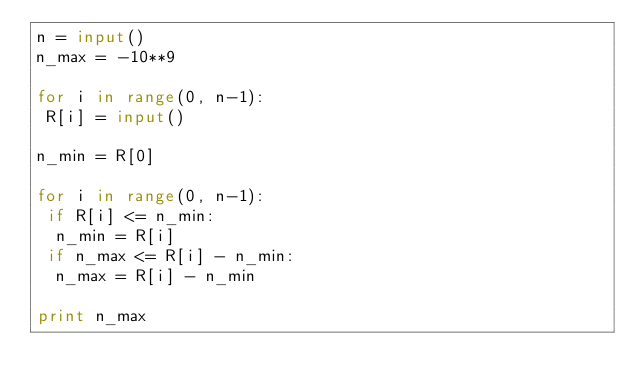<code> <loc_0><loc_0><loc_500><loc_500><_Python_>n = input()
n_max = -10**9
 
for i in range(0, n-1):
 R[i] = input()

n_min = R[0]

for i in range(0, n-1):
 if R[i] <= n_min:
  n_min = R[i]
 if n_max <= R[i] - n_min:
  n_max = R[i] - n_min
 
print n_max</code> 